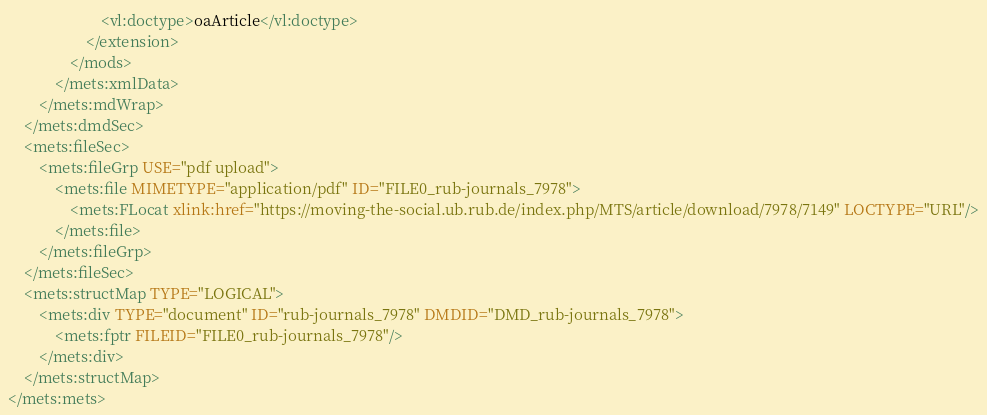<code> <loc_0><loc_0><loc_500><loc_500><_XML_>                        <vl:doctype>oaArticle</vl:doctype>
                    </extension>
                </mods>
            </mets:xmlData>
        </mets:mdWrap>
    </mets:dmdSec>
    <mets:fileSec>
        <mets:fileGrp USE="pdf upload">
            <mets:file MIMETYPE="application/pdf" ID="FILE0_rub-journals_7978">
                <mets:FLocat xlink:href="https://moving-the-social.ub.rub.de/index.php/MTS/article/download/7978/7149" LOCTYPE="URL"/>
            </mets:file>
        </mets:fileGrp>
    </mets:fileSec>
    <mets:structMap TYPE="LOGICAL">
        <mets:div TYPE="document" ID="rub-journals_7978" DMDID="DMD_rub-journals_7978">
            <mets:fptr FILEID="FILE0_rub-journals_7978"/>
        </mets:div>
    </mets:structMap>
</mets:mets>
</code> 